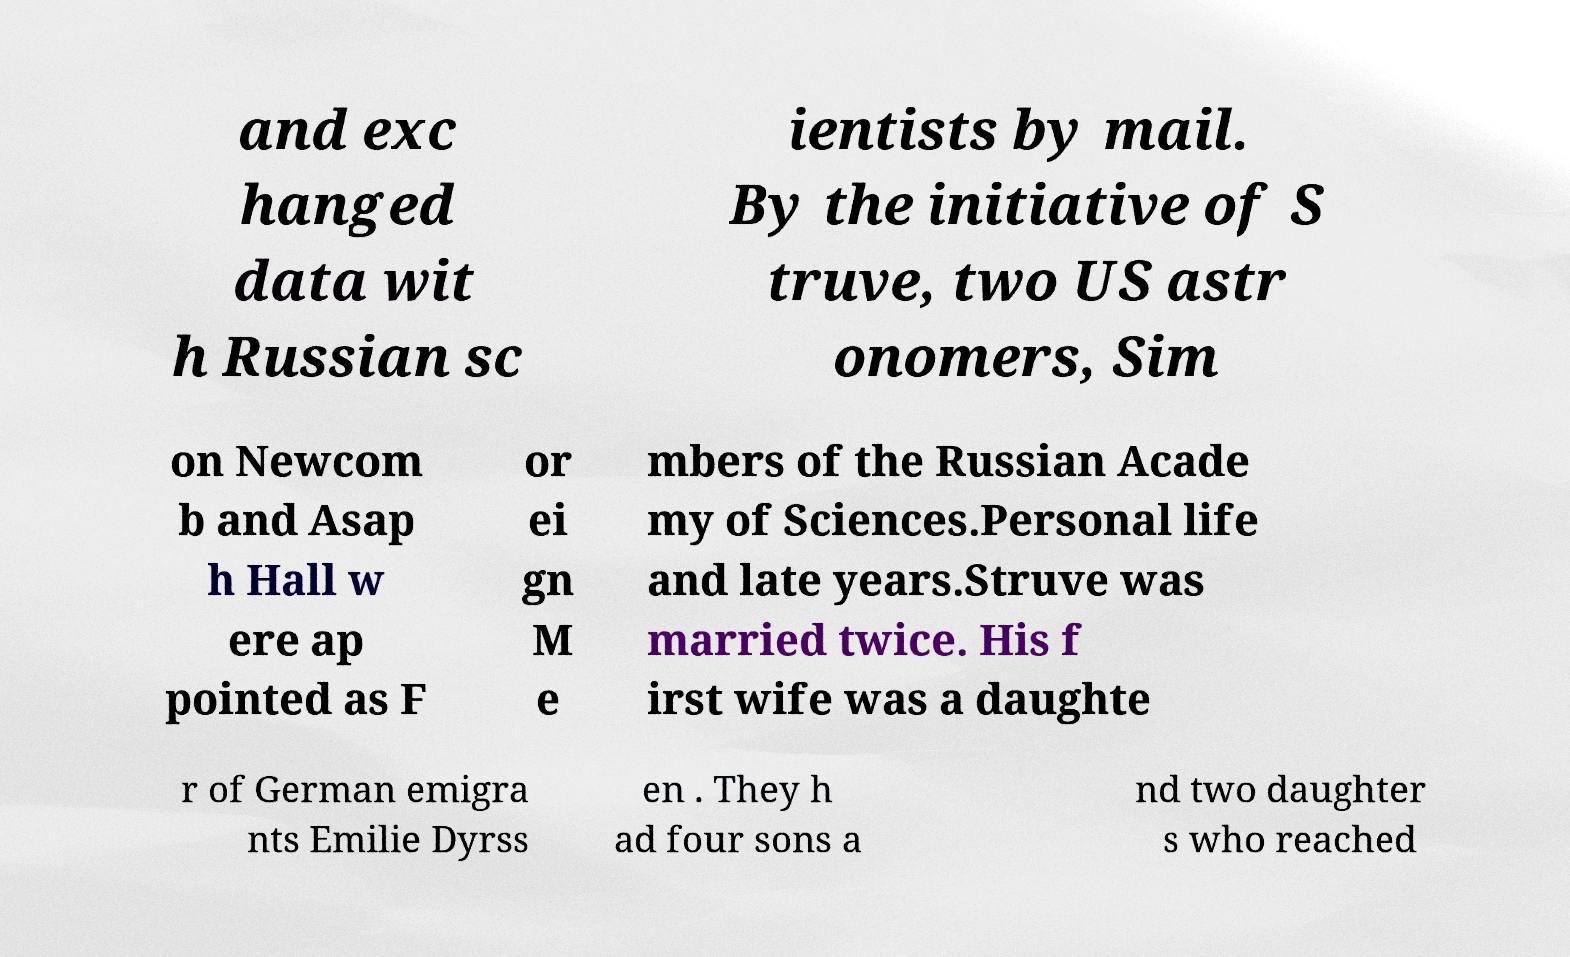Could you assist in decoding the text presented in this image and type it out clearly? and exc hanged data wit h Russian sc ientists by mail. By the initiative of S truve, two US astr onomers, Sim on Newcom b and Asap h Hall w ere ap pointed as F or ei gn M e mbers of the Russian Acade my of Sciences.Personal life and late years.Struve was married twice. His f irst wife was a daughte r of German emigra nts Emilie Dyrss en . They h ad four sons a nd two daughter s who reached 